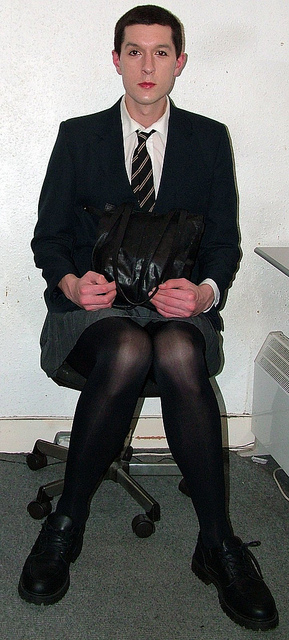<image>What is the term for this person? The term for this person is ambiguous. They could be referred to as a man, transvestite, or crossdresser among others. What is the term for this person? I don't know what is the term for this person. It can be seen as a man, transvestite, fashion, tranny, crossdresser, or hermaphrodite. 